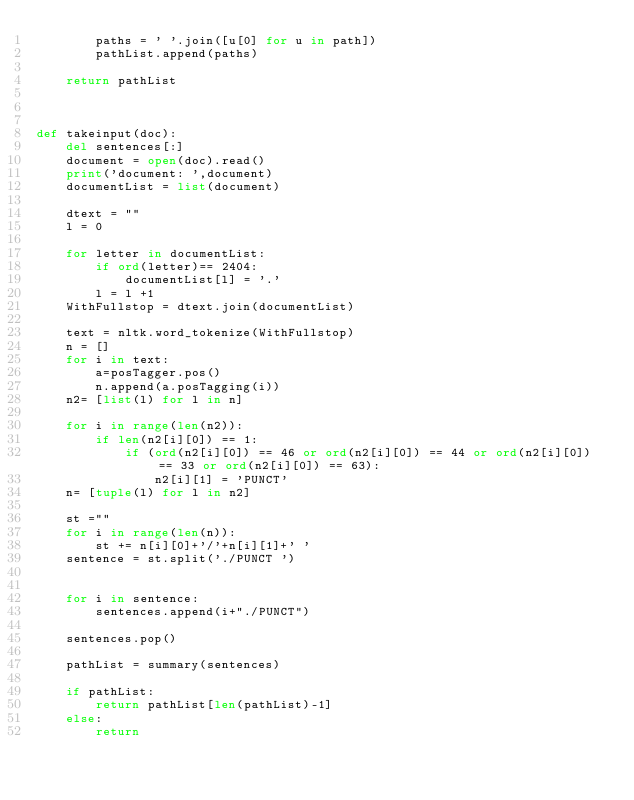Convert code to text. <code><loc_0><loc_0><loc_500><loc_500><_Python_>        paths = ' '.join([u[0] for u in path])
        pathList.append(paths)
    
    return pathList


    
def takeinput(doc):
    del sentences[:]
    document = open(doc).read()
    print('document: ',document)
    documentList = list(document)
    
    dtext = ""
    l = 0
    
    for letter in documentList:    
        if ord(letter)== 2404:
            documentList[l] = '.'
        l = l +1
    WithFullstop = dtext.join(documentList)
    
    text = nltk.word_tokenize(WithFullstop)
    n = []
    for i in text:
        a=posTagger.pos()
        n.append(a.posTagging(i))
    n2= [list(l) for l in n]

    for i in range(len(n2)):
        if len(n2[i][0]) == 1:
            if (ord(n2[i][0]) == 46 or ord(n2[i][0]) == 44 or ord(n2[i][0]) == 33 or ord(n2[i][0]) == 63):
                n2[i][1] = 'PUNCT'
    n= [tuple(l) for l in n2]
    
    st =""
    for i in range(len(n)):
        st += n[i][0]+'/'+n[i][1]+' '
    sentence = st.split('./PUNCT ')
    
    
    for i in sentence:
        sentences.append(i+"./PUNCT")
        
    sentences.pop()    

    pathList = summary(sentences)

    if pathList:
        return pathList[len(pathList)-1]
    else: 
        return



</code> 